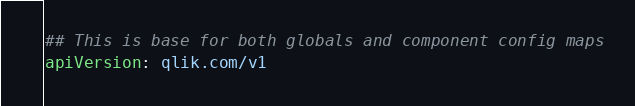Convert code to text. <code><loc_0><loc_0><loc_500><loc_500><_YAML_>## This is base for both globals and component config maps
apiVersion: qlik.com/v1</code> 